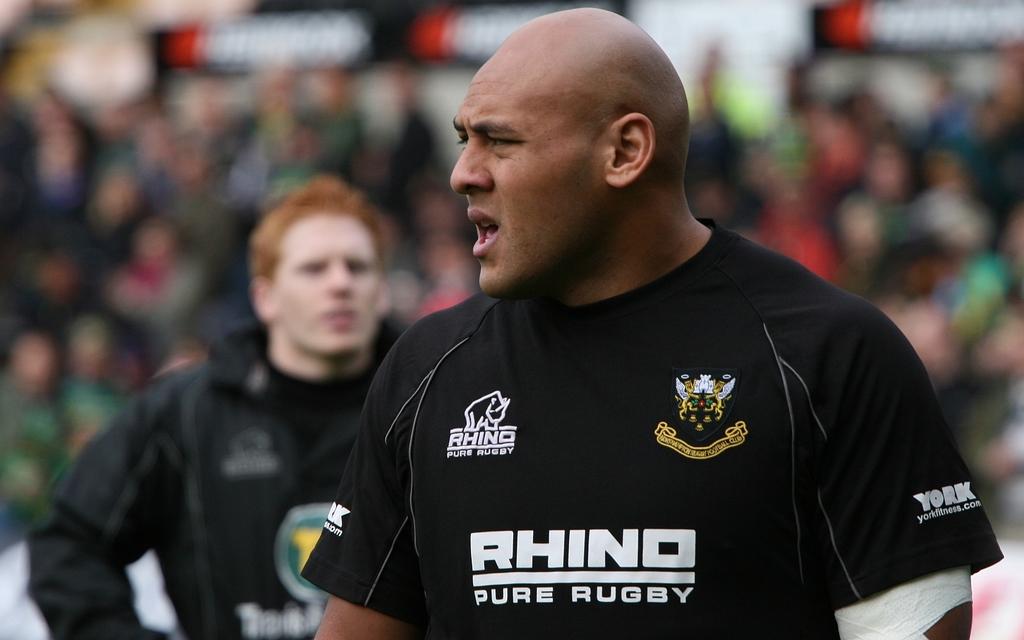What sport is this shirt for?
Your answer should be very brief. Rugby. Who sponsors this team?
Give a very brief answer. Rhino. 